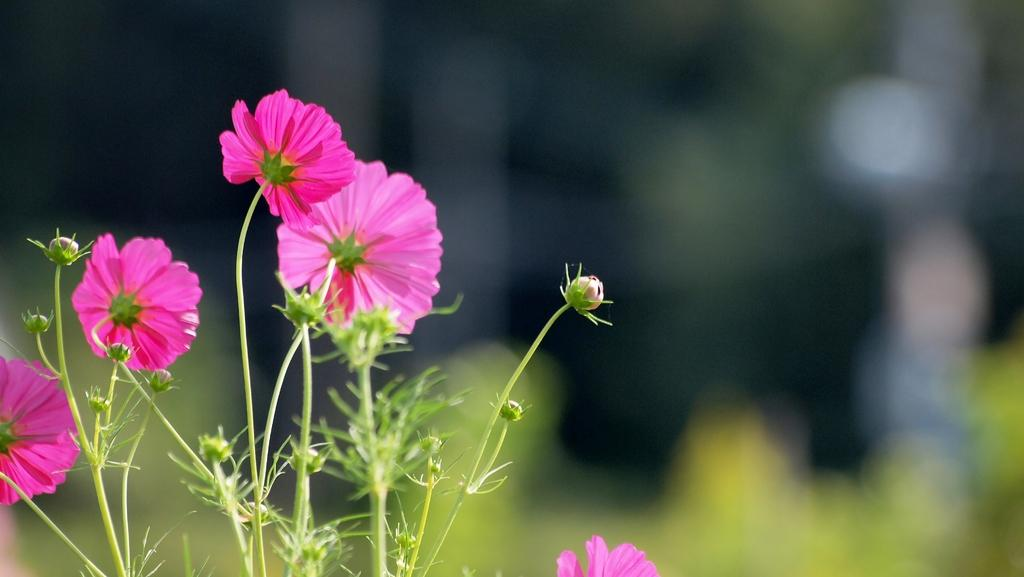What type of flowers can be seen in the image? There are pink flowers in the image. Are there any flowers in the image that are not fully bloomed? Yes, there are buds in the image. How would you describe the background of the image? The background of the image is blurred. Is there a hose visible in the image? No, there is no hose present in the image. What type of button can be seen on the flowers in the image? There are no buttons on the flowers in the image; they are natural flowers. 